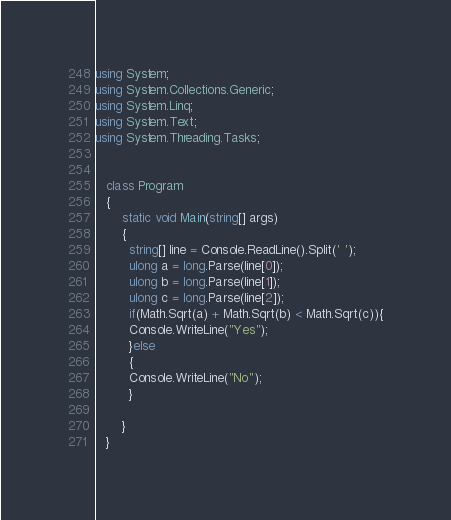Convert code to text. <code><loc_0><loc_0><loc_500><loc_500><_C#_>using System;
using System.Collections.Generic;
using System.Linq;
using System.Text;
using System.Threading.Tasks;


   class Program
   {
       static void Main(string[] args)
       {
         string[] line = Console.ReadLine().Split(' ');
         ulong a = long.Parse(line[0]);
         ulong b = long.Parse(line[1]);
         ulong c = long.Parse(line[2]);
         if(Math.Sqrt(a) + Math.Sqrt(b) < Math.Sqrt(c)){
         Console.WriteLine("Yes");
         }else
         {
         Console.WriteLine("No");
         }
         
       }
   }
</code> 